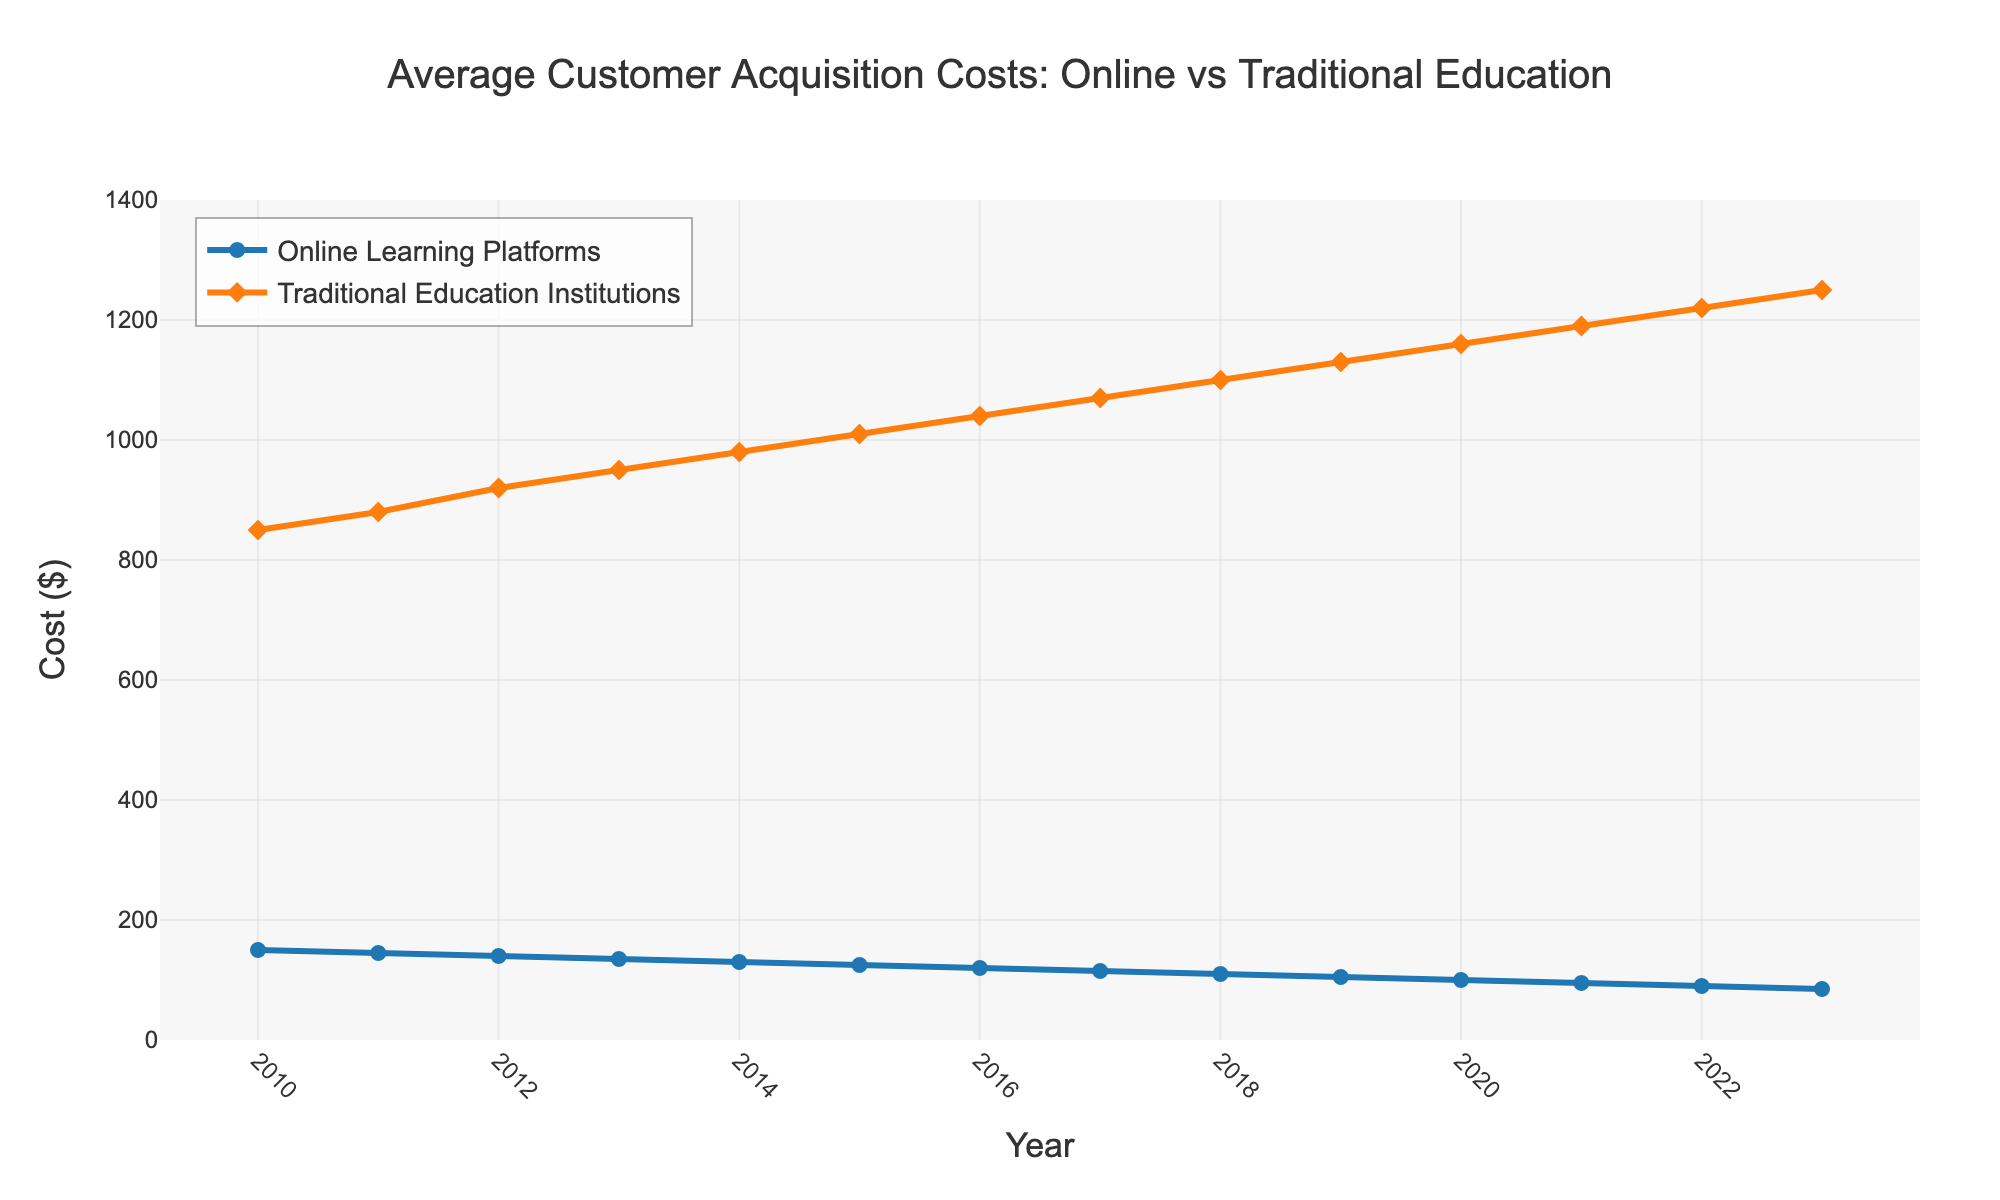How do the average customer acquisition costs for online learning platforms compare to traditional education institutions in 2010? In 2010, the cost for online learning platforms is $150, while for traditional education institutions, it is $850. Thus, traditional institutions' costs are significantly higher.
Answer: Traditional institutions' costs are higher What is the trend in the average customer acquisition costs for online learning platforms from 2010 to 2023? From 2010 to 2023, the average customer acquisition costs for online learning platforms show a consistent decrease, starting at $150 in 2010 and dropping to $85 in 2023.
Answer: Decreasing trend What's the percentage decrease in the average customer acquisition costs for online learning platforms from 2010 to 2023? The initial cost in 2010 is $150 and the final cost in 2023 is $85. The percentage decrease is calculated by [(150 - 85) / 150] * 100.
Answer: 43.33% Which year had the largest gap in customer acquisition costs between online learning platforms and traditional education institutions? To find the largest gap, we can examine the given data. The year with the biggest difference is 2010, where the gap is $850 - $150 = $700.
Answer: 2010 Do traditional education institutions ever show a decreasing trend in their customer acquisition costs? Observing the data from 2010 to 2023, the costs for traditional education institutions steadily increase each year, indicating no periods of decline.
Answer: No In what year do customer acquisition costs for online learning platforms drop below $100? From the data, the first year the costs for online learning platforms drop below $100 is in 2020, where the cost is $100.
Answer: 2020 Compare the rate of change in the average customer acquisition costs for online learning platforms versus traditional education institutions from 2010 to 2023. Online learning platforms exhibit a decreasing trend with a total reduction of $150 - $85 = $65 over 13 years. Traditional education institutions show an increasing trend with a total increase of $1250 - $850 = $400 over the same period. The rate of change is more drastic for traditional education institutions.
Answer: Traditional institutions have a steeper rate of change How do the markers used to represent online learning platforms differ visually from those representing traditional education institutions? The online learning platforms are represented with circle markers, while traditional education institutions are denoted with diamond markers.
Answer: Circle vs. Diamond 